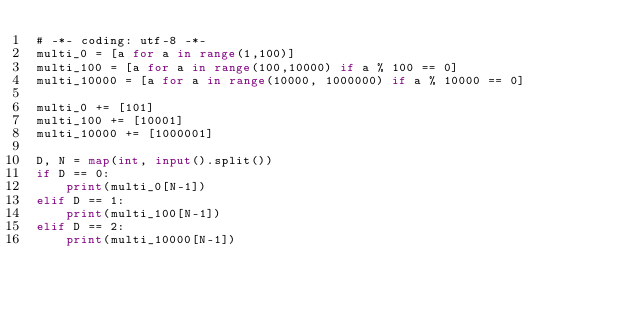<code> <loc_0><loc_0><loc_500><loc_500><_Python_># -*- coding: utf-8 -*-
multi_0 = [a for a in range(1,100)]
multi_100 = [a for a in range(100,10000) if a % 100 == 0]
multi_10000 = [a for a in range(10000, 1000000) if a % 10000 == 0]

multi_0 += [101]
multi_100 += [10001]
multi_10000 += [1000001]

D, N = map(int, input().split())
if D == 0:
    print(multi_0[N-1])
elif D == 1:
    print(multi_100[N-1])
elif D == 2:
    print(multi_10000[N-1])</code> 